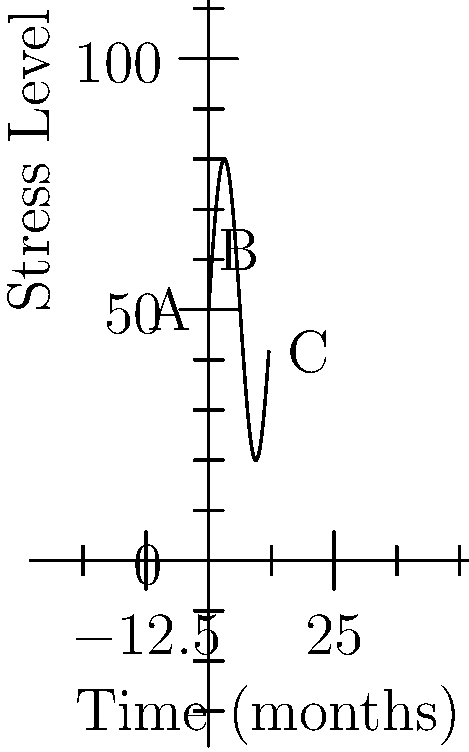The graph represents the stress levels of employees in a workplace over a 12-month period. If the curve is given by the function $f(t) = 50 + 30\sin(\frac{t}{2})$, where $t$ is time in months and $f(t)$ is the stress level, at what point in time is the rate of change of stress level equal to zero? To find when the rate of change of stress level is zero, we need to follow these steps:

1) The rate of change is represented by the derivative of the function. Let's find $f'(t)$:
   
   $f'(t) = 30 \cdot \frac{1}{2} \cos(\frac{t}{2}) = 15\cos(\frac{t}{2})$

2) The rate of change is zero when $f'(t) = 0$:
   
   $15\cos(\frac{t}{2}) = 0$

3) Solve this equation:
   
   $\cos(\frac{t}{2}) = 0$
   
   This occurs when $\frac{t}{2} = \frac{\pi}{2}, \frac{3\pi}{2}, \frac{5\pi}{2}$, etc.

4) Solve for $t$:
   
   $t = \pi, 3\pi, 5\pi$, etc.

5) Convert to months (since $t$ is in months and the graph shows 12 months):
   
   $t \approx 3.14, 9.42, 15.71$, etc.

6) The value within the given 12-month period is approximately 3.14 months.

This point corresponds to the peak B on the graph, where the curve transitions from increasing to decreasing.
Answer: Approximately 3.14 months 